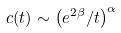<formula> <loc_0><loc_0><loc_500><loc_500>c ( t ) \sim \left ( e ^ { 2 \beta } / t \right ) ^ { \alpha }</formula> 